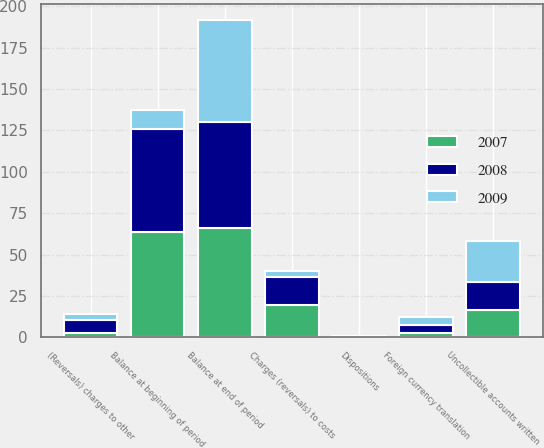<chart> <loc_0><loc_0><loc_500><loc_500><stacked_bar_chart><ecel><fcel>Balance at beginning of period<fcel>Charges (reversals) to costs<fcel>(Reversals) charges to other<fcel>Dispositions<fcel>Uncollectible accounts written<fcel>Foreign currency translation<fcel>Balance at end of period<nl><fcel>2007<fcel>63.9<fcel>19.3<fcel>2.8<fcel>0.2<fcel>16.5<fcel>2.3<fcel>66<nl><fcel>2008<fcel>61.8<fcel>17<fcel>7.4<fcel>0.2<fcel>17.1<fcel>5<fcel>63.9<nl><fcel>2009<fcel>11.95<fcel>3.6<fcel>3.9<fcel>0.5<fcel>24.3<fcel>5<fcel>61.8<nl></chart> 